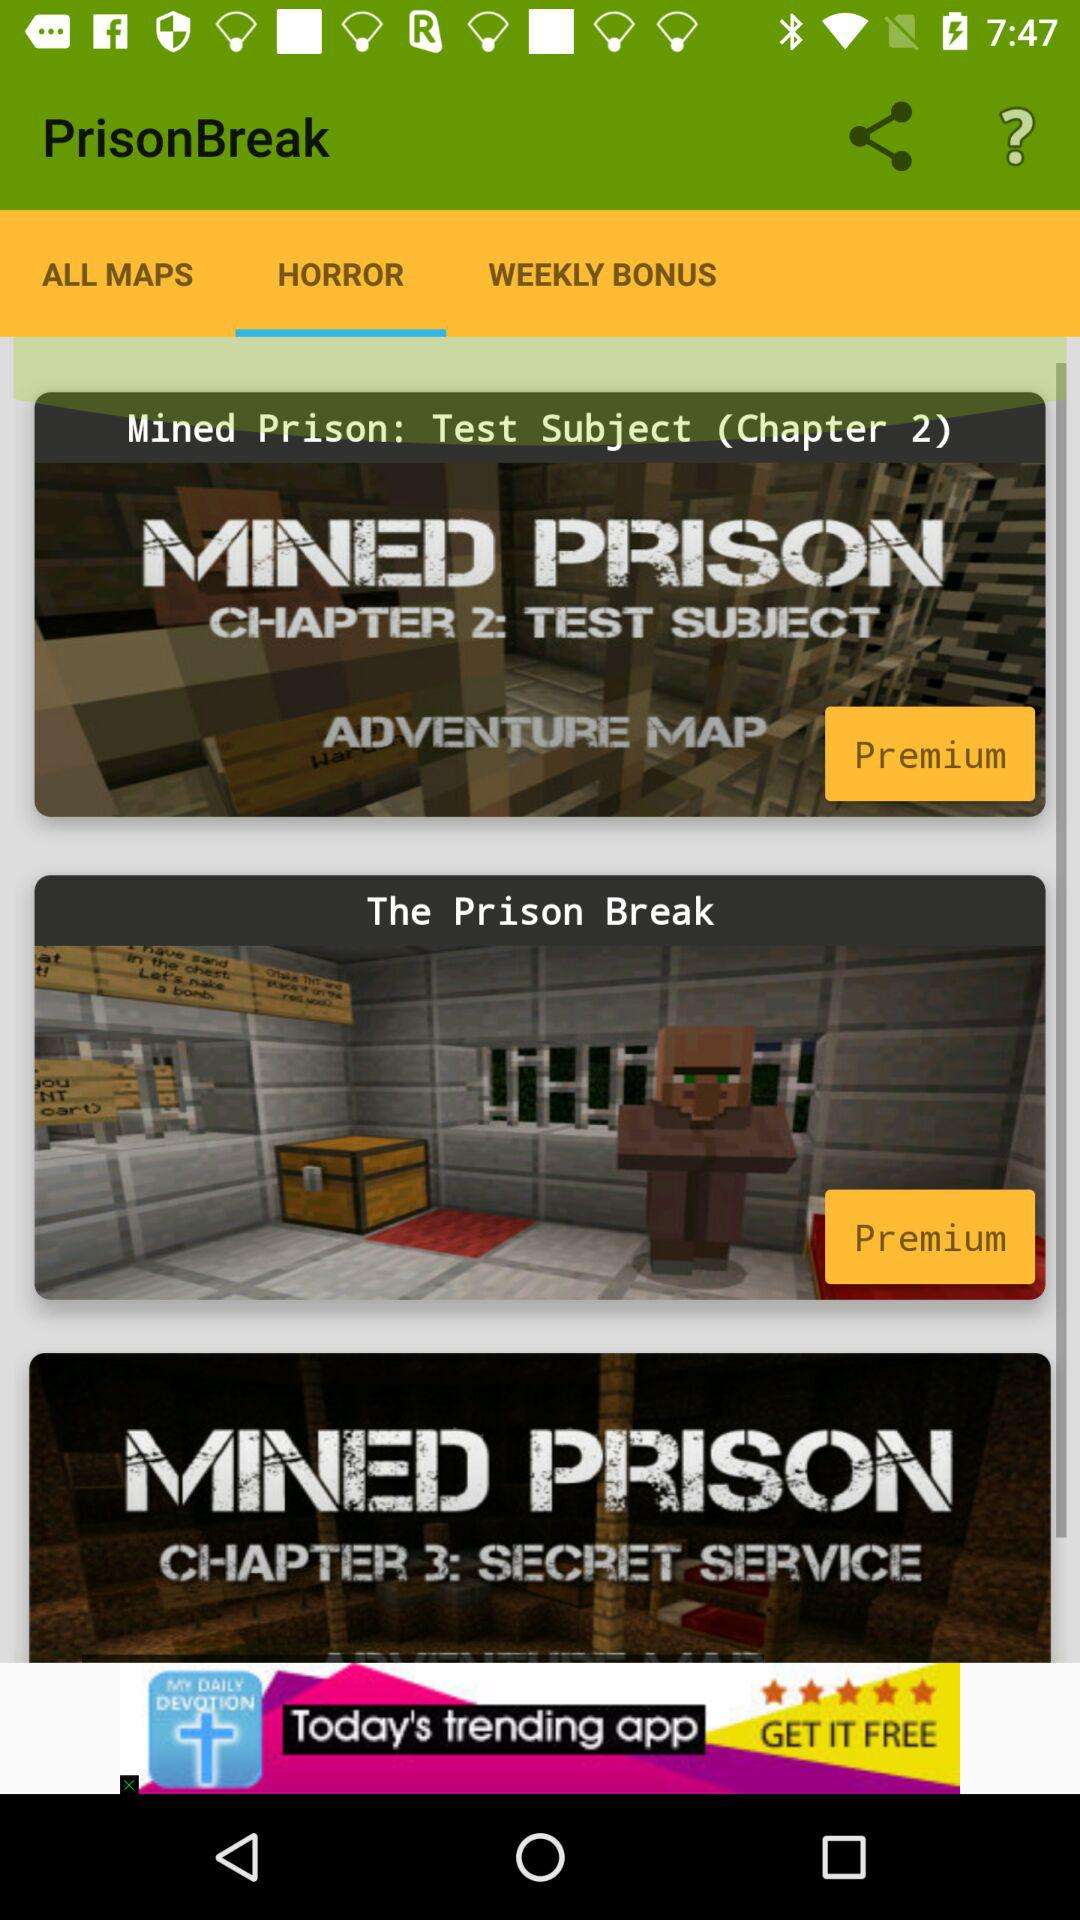What is the title of Chapter 2? The title of Chapter 2 is "Mined Prison: Test Subject". 